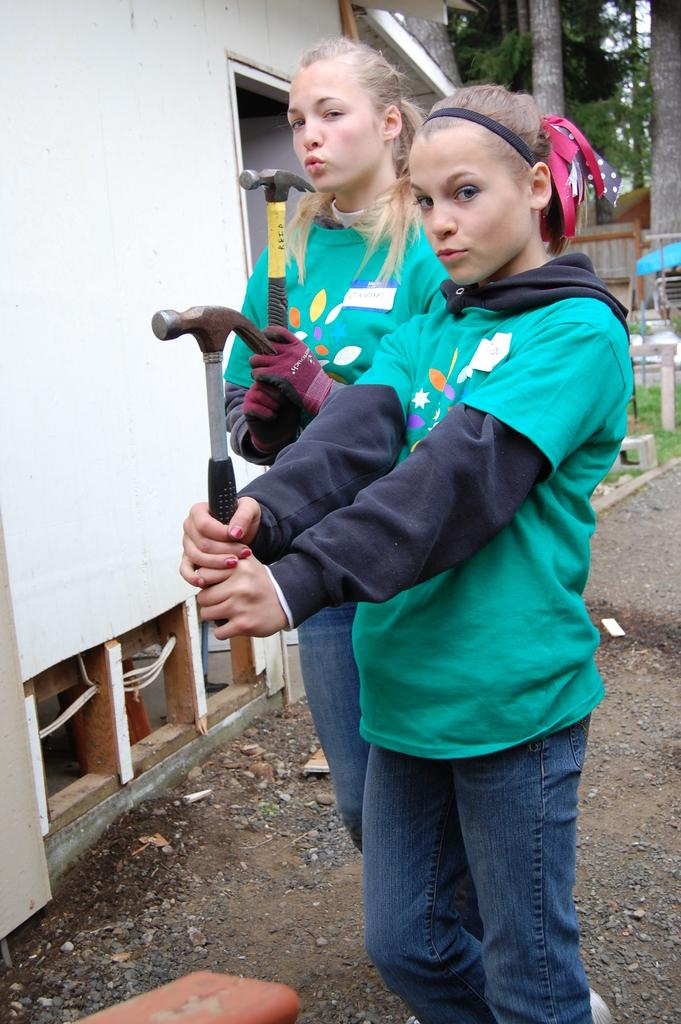How many women are in the image? There are two women in the image. What are the women doing in the image? The women are standing on the ground and holding hammers in their hands. What can be seen in the background of the image? There are trees and a house in the background of the image. What type of jewel is the woman wearing on her finger in the image? There is no mention of a jewel or a woman wearing a jewel in the image. 